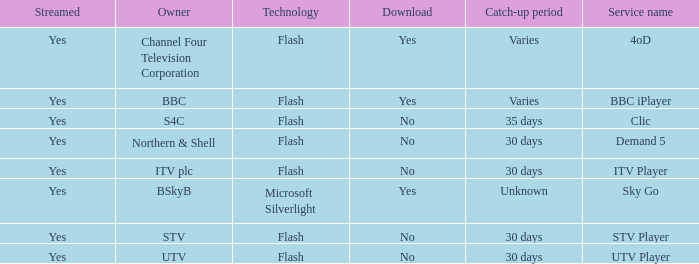What is the Service name of BBC? BBC iPlayer. 